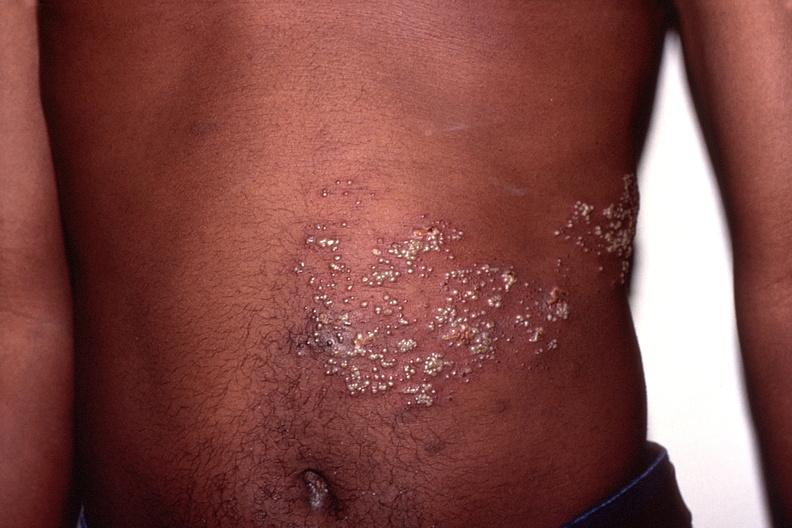does retroperitoneal leiomyosarcoma show herpes zoster?
Answer the question using a single word or phrase. No 